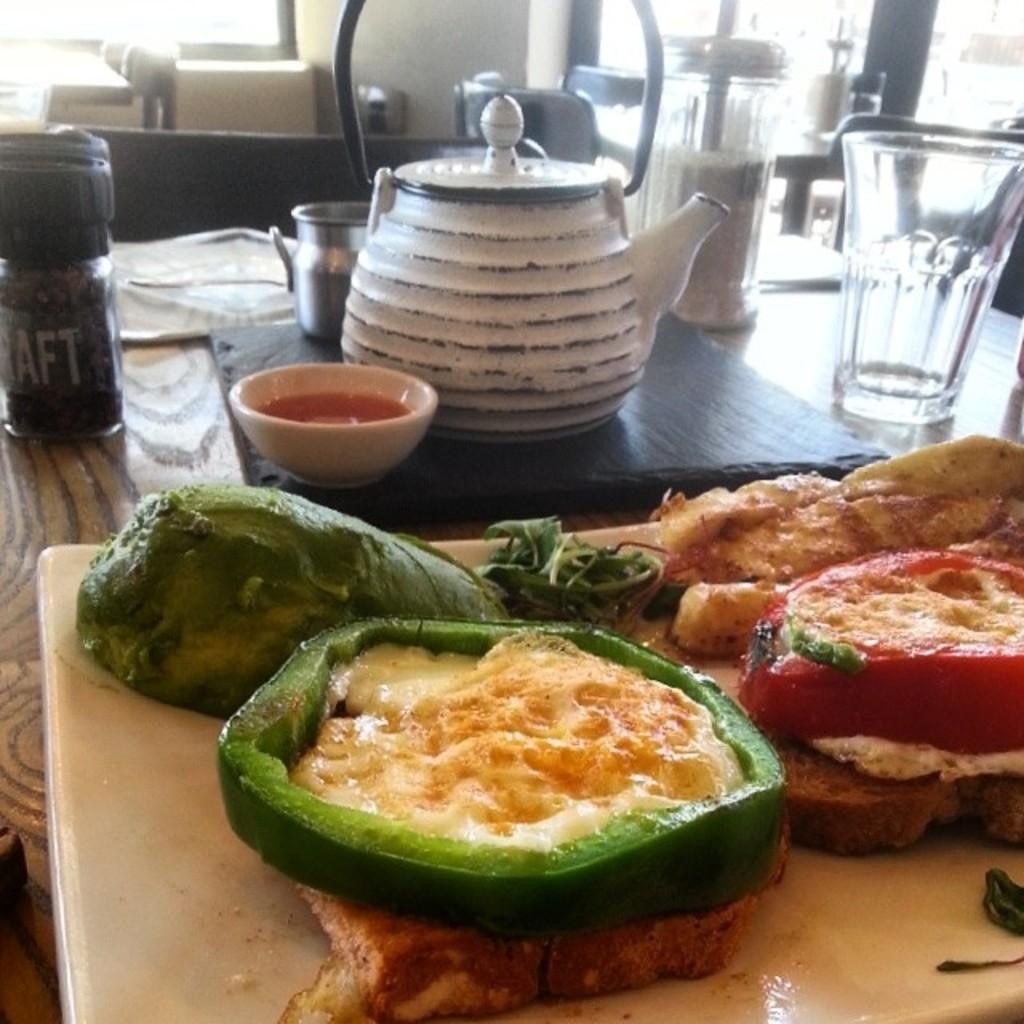Can you describe this image briefly? In this picture there is a table in the center of the image on which, there is a glass, kettle, bowl and food items on the chopping pad, there are other kitchenware, which are placed on the table. 